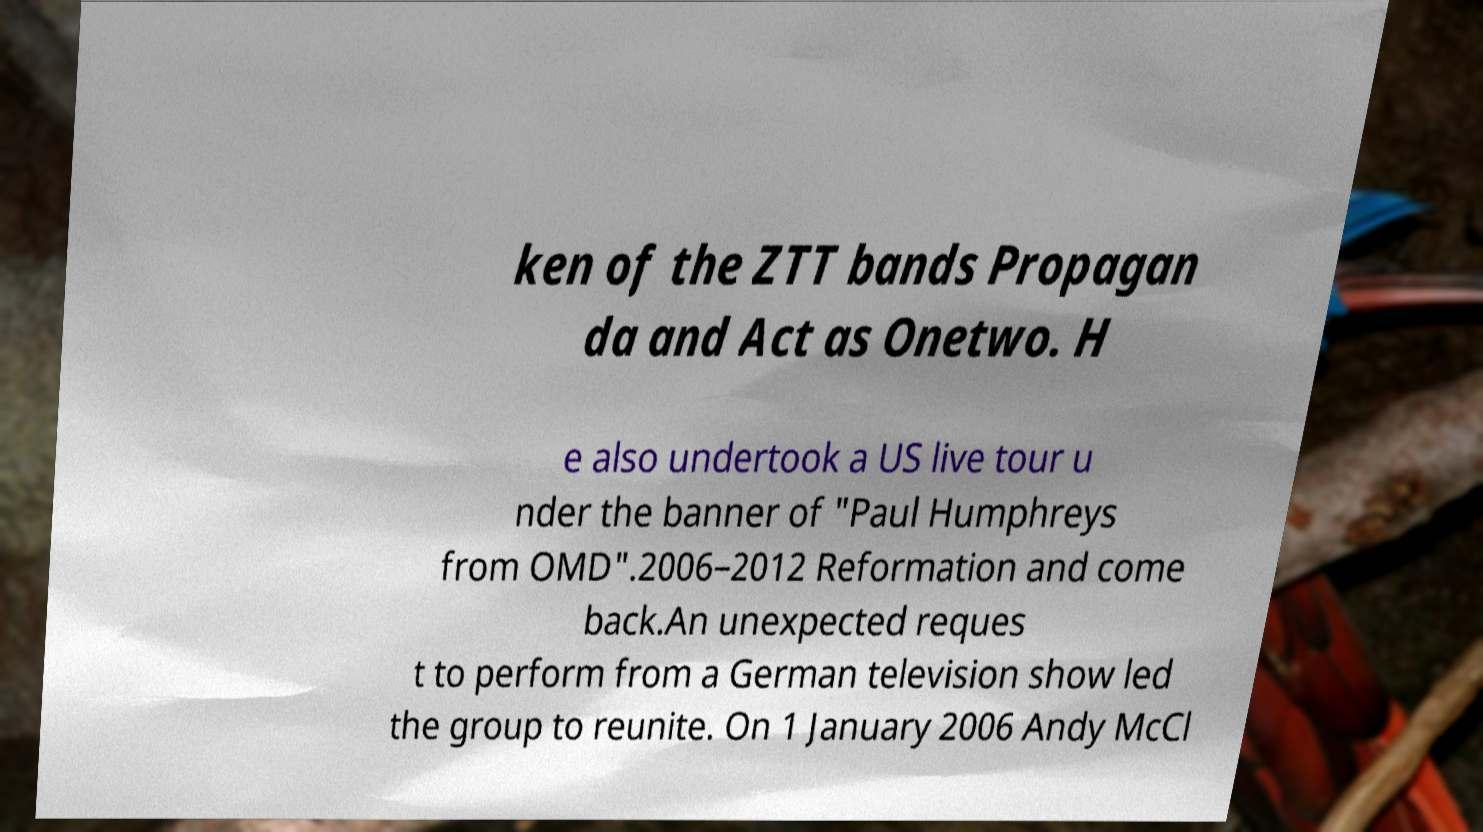Please read and relay the text visible in this image. What does it say? ken of the ZTT bands Propagan da and Act as Onetwo. H e also undertook a US live tour u nder the banner of "Paul Humphreys from OMD".2006–2012 Reformation and come back.An unexpected reques t to perform from a German television show led the group to reunite. On 1 January 2006 Andy McCl 